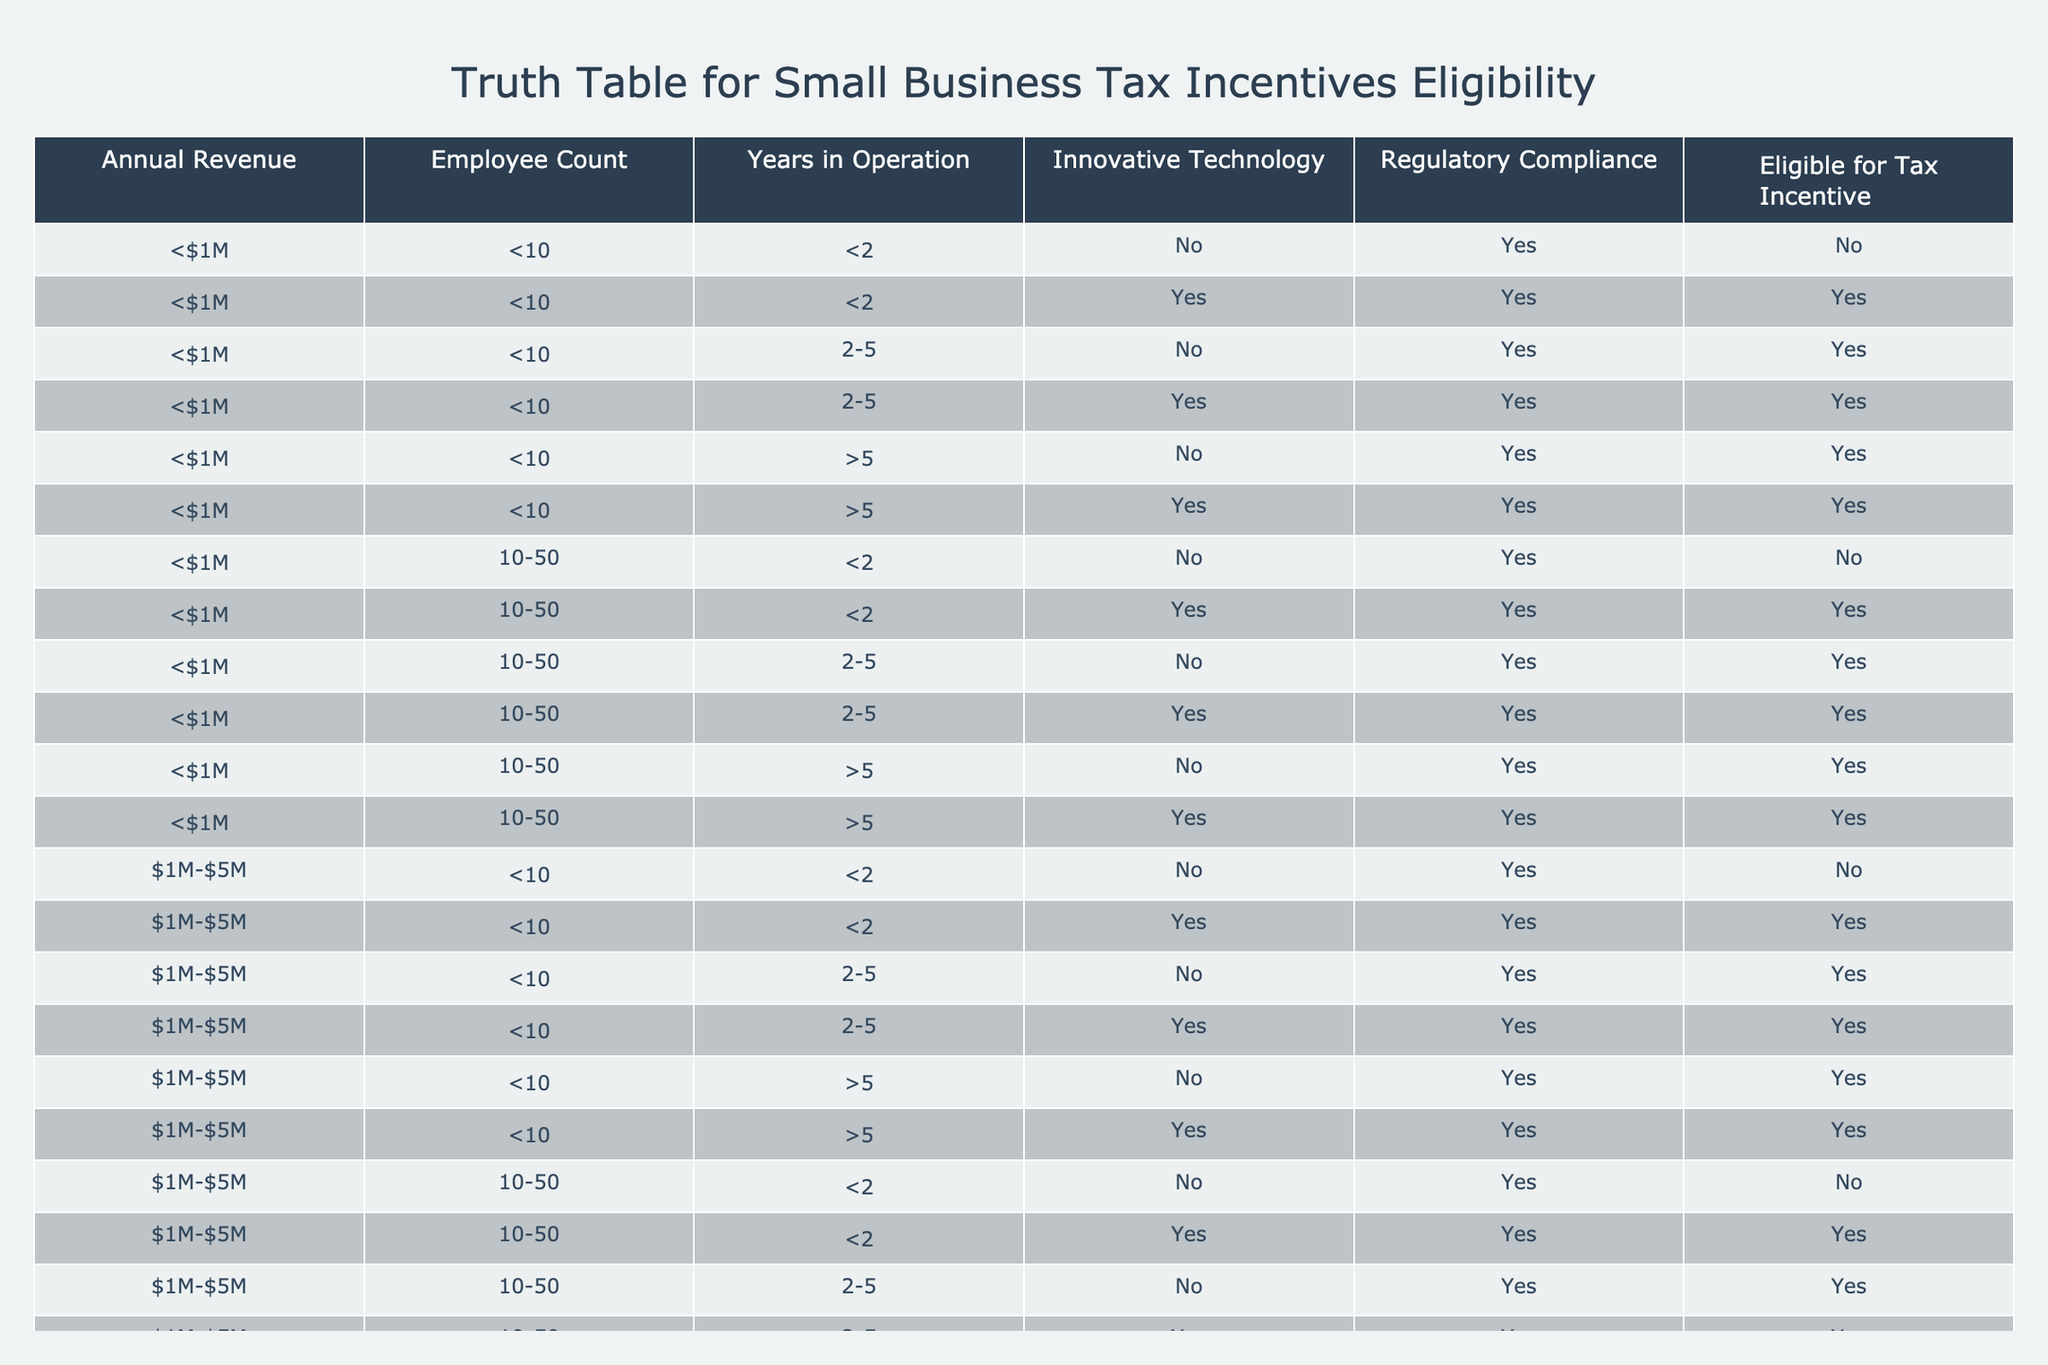What percentage of businesses with annual revenue less than $1M and more than 5 years in operation are eligible for tax incentives? There are 6 businesses fitting this criterion in the table. Out of those, 5 are eligible for tax incentives. So, the percentage is (5/6) * 100 = 83.33%.
Answer: 83.33% What is the eligibility for tax incentives for businesses with innovative technology and between 10-50 employees? Looking at the table, all businesses with innovative technology and 10-50 employees, regardless of their revenue or years in operation, are listed as eligible for tax incentives.
Answer: Yes Are there any businesses with annual revenue over $5M that are eligible for tax incentives? Reviewing the table, all businesses listed with annual revenue over $5M have a 'No' in the eligibility column, indicating they are not eligible for tax incentives.
Answer: No How many total businesses are eligible for tax incentives with less than $1M in annual revenue? There are 9 businesses with less than $1M in annual revenue that are eligible for tax incentives, as observed in the relevant rows of the table.
Answer: 9 What's the difference in the number of eligible businesses between those with annual revenue of $1M-$5M and those with over $5M? For $1M-$5M revenue, there are 12 eligible businesses. For over $5M revenue, there are 2 eligible businesses. The difference is 12 - 0 = 12.
Answer: 12 How many businesses with less than $1M in annual revenue are eligible for tax incentives if they have less than 10 employees and between 2 to 5 years of operation? There are 2 businesses fitting this description in the table that are eligible for tax incentives, looking specifically at that employee count and years of operation.
Answer: 2 Is it true that all businesses with less than $1M revenue are eligible if they use innovative technology? From the table, all instances of businesses with less than $1M revenue and innovative technology are eligible for tax incentives, confirming the statement is true.
Answer: Yes How many unique combinations of employee count and years of operation result in businesses being eligible for tax incentives with an annual revenue of $1M-$5M? The eligible businesses with $1M-$5M annual revenue show 6 unique combinations: (<10,<2), (<10,2-5), (<10,>5), (10-50,<2), (10-50,2-5), and (10-50,>5).
Answer: 6 Are there any instances of businesses with regulatory compliance being ineligible for tax incentives? By examining the table, there are no instances where businesses marked as compliant with regulations are ineligible for tax incentives.
Answer: No 